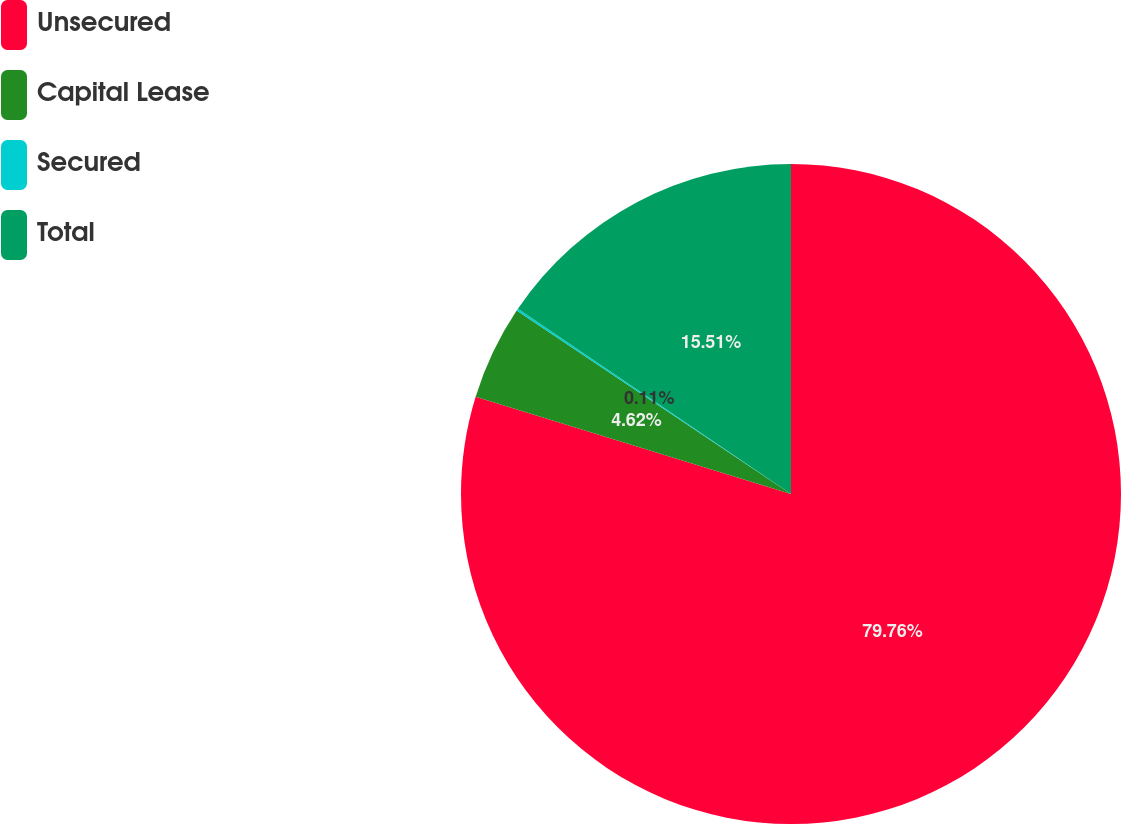Convert chart. <chart><loc_0><loc_0><loc_500><loc_500><pie_chart><fcel>Unsecured<fcel>Capital Lease<fcel>Secured<fcel>Total<nl><fcel>79.76%<fcel>4.62%<fcel>0.11%<fcel>15.51%<nl></chart> 